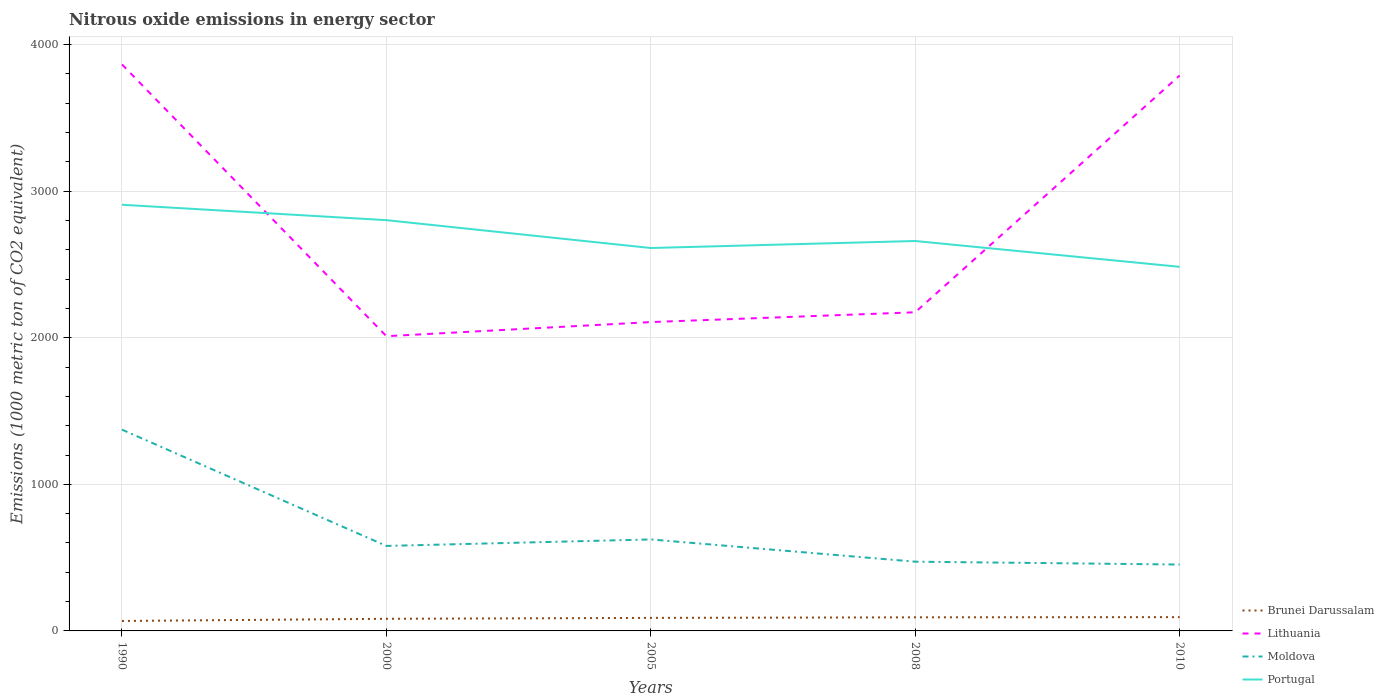How many different coloured lines are there?
Your answer should be compact. 4. Does the line corresponding to Moldova intersect with the line corresponding to Brunei Darussalam?
Offer a very short reply. No. Is the number of lines equal to the number of legend labels?
Give a very brief answer. Yes. Across all years, what is the maximum amount of nitrous oxide emitted in Moldova?
Give a very brief answer. 452.9. In which year was the amount of nitrous oxide emitted in Moldova maximum?
Your response must be concise. 2010. What is the total amount of nitrous oxide emitted in Moldova in the graph?
Offer a terse response. 793.4. What is the difference between the highest and the second highest amount of nitrous oxide emitted in Portugal?
Your answer should be very brief. 423.5. What is the difference between the highest and the lowest amount of nitrous oxide emitted in Portugal?
Your answer should be very brief. 2. Does the graph contain grids?
Keep it short and to the point. Yes. How are the legend labels stacked?
Keep it short and to the point. Vertical. What is the title of the graph?
Offer a very short reply. Nitrous oxide emissions in energy sector. What is the label or title of the X-axis?
Provide a short and direct response. Years. What is the label or title of the Y-axis?
Your response must be concise. Emissions (1000 metric ton of CO2 equivalent). What is the Emissions (1000 metric ton of CO2 equivalent) in Brunei Darussalam in 1990?
Make the answer very short. 67.9. What is the Emissions (1000 metric ton of CO2 equivalent) of Lithuania in 1990?
Give a very brief answer. 3865. What is the Emissions (1000 metric ton of CO2 equivalent) in Moldova in 1990?
Your answer should be compact. 1373.3. What is the Emissions (1000 metric ton of CO2 equivalent) in Portugal in 1990?
Offer a very short reply. 2907.5. What is the Emissions (1000 metric ton of CO2 equivalent) in Brunei Darussalam in 2000?
Provide a succinct answer. 82.7. What is the Emissions (1000 metric ton of CO2 equivalent) in Lithuania in 2000?
Your answer should be compact. 2010.8. What is the Emissions (1000 metric ton of CO2 equivalent) in Moldova in 2000?
Offer a terse response. 579.9. What is the Emissions (1000 metric ton of CO2 equivalent) in Portugal in 2000?
Your answer should be very brief. 2802.4. What is the Emissions (1000 metric ton of CO2 equivalent) of Brunei Darussalam in 2005?
Offer a very short reply. 88.9. What is the Emissions (1000 metric ton of CO2 equivalent) of Lithuania in 2005?
Give a very brief answer. 2107. What is the Emissions (1000 metric ton of CO2 equivalent) in Moldova in 2005?
Keep it short and to the point. 624.1. What is the Emissions (1000 metric ton of CO2 equivalent) of Portugal in 2005?
Your answer should be very brief. 2612.4. What is the Emissions (1000 metric ton of CO2 equivalent) in Brunei Darussalam in 2008?
Give a very brief answer. 92.7. What is the Emissions (1000 metric ton of CO2 equivalent) in Lithuania in 2008?
Make the answer very short. 2173.9. What is the Emissions (1000 metric ton of CO2 equivalent) of Moldova in 2008?
Provide a short and direct response. 472.4. What is the Emissions (1000 metric ton of CO2 equivalent) in Portugal in 2008?
Provide a succinct answer. 2660.2. What is the Emissions (1000 metric ton of CO2 equivalent) in Brunei Darussalam in 2010?
Give a very brief answer. 94.1. What is the Emissions (1000 metric ton of CO2 equivalent) in Lithuania in 2010?
Give a very brief answer. 3789.1. What is the Emissions (1000 metric ton of CO2 equivalent) of Moldova in 2010?
Keep it short and to the point. 452.9. What is the Emissions (1000 metric ton of CO2 equivalent) in Portugal in 2010?
Your answer should be very brief. 2484. Across all years, what is the maximum Emissions (1000 metric ton of CO2 equivalent) of Brunei Darussalam?
Your response must be concise. 94.1. Across all years, what is the maximum Emissions (1000 metric ton of CO2 equivalent) in Lithuania?
Offer a very short reply. 3865. Across all years, what is the maximum Emissions (1000 metric ton of CO2 equivalent) in Moldova?
Keep it short and to the point. 1373.3. Across all years, what is the maximum Emissions (1000 metric ton of CO2 equivalent) in Portugal?
Give a very brief answer. 2907.5. Across all years, what is the minimum Emissions (1000 metric ton of CO2 equivalent) in Brunei Darussalam?
Offer a very short reply. 67.9. Across all years, what is the minimum Emissions (1000 metric ton of CO2 equivalent) of Lithuania?
Keep it short and to the point. 2010.8. Across all years, what is the minimum Emissions (1000 metric ton of CO2 equivalent) in Moldova?
Offer a terse response. 452.9. Across all years, what is the minimum Emissions (1000 metric ton of CO2 equivalent) in Portugal?
Provide a succinct answer. 2484. What is the total Emissions (1000 metric ton of CO2 equivalent) in Brunei Darussalam in the graph?
Your answer should be very brief. 426.3. What is the total Emissions (1000 metric ton of CO2 equivalent) in Lithuania in the graph?
Your answer should be compact. 1.39e+04. What is the total Emissions (1000 metric ton of CO2 equivalent) of Moldova in the graph?
Offer a very short reply. 3502.6. What is the total Emissions (1000 metric ton of CO2 equivalent) in Portugal in the graph?
Offer a terse response. 1.35e+04. What is the difference between the Emissions (1000 metric ton of CO2 equivalent) in Brunei Darussalam in 1990 and that in 2000?
Provide a short and direct response. -14.8. What is the difference between the Emissions (1000 metric ton of CO2 equivalent) in Lithuania in 1990 and that in 2000?
Ensure brevity in your answer.  1854.2. What is the difference between the Emissions (1000 metric ton of CO2 equivalent) in Moldova in 1990 and that in 2000?
Your answer should be very brief. 793.4. What is the difference between the Emissions (1000 metric ton of CO2 equivalent) in Portugal in 1990 and that in 2000?
Your answer should be very brief. 105.1. What is the difference between the Emissions (1000 metric ton of CO2 equivalent) in Brunei Darussalam in 1990 and that in 2005?
Give a very brief answer. -21. What is the difference between the Emissions (1000 metric ton of CO2 equivalent) in Lithuania in 1990 and that in 2005?
Keep it short and to the point. 1758. What is the difference between the Emissions (1000 metric ton of CO2 equivalent) in Moldova in 1990 and that in 2005?
Offer a terse response. 749.2. What is the difference between the Emissions (1000 metric ton of CO2 equivalent) in Portugal in 1990 and that in 2005?
Your answer should be very brief. 295.1. What is the difference between the Emissions (1000 metric ton of CO2 equivalent) of Brunei Darussalam in 1990 and that in 2008?
Keep it short and to the point. -24.8. What is the difference between the Emissions (1000 metric ton of CO2 equivalent) in Lithuania in 1990 and that in 2008?
Offer a terse response. 1691.1. What is the difference between the Emissions (1000 metric ton of CO2 equivalent) in Moldova in 1990 and that in 2008?
Ensure brevity in your answer.  900.9. What is the difference between the Emissions (1000 metric ton of CO2 equivalent) of Portugal in 1990 and that in 2008?
Offer a very short reply. 247.3. What is the difference between the Emissions (1000 metric ton of CO2 equivalent) of Brunei Darussalam in 1990 and that in 2010?
Your answer should be compact. -26.2. What is the difference between the Emissions (1000 metric ton of CO2 equivalent) in Lithuania in 1990 and that in 2010?
Provide a short and direct response. 75.9. What is the difference between the Emissions (1000 metric ton of CO2 equivalent) of Moldova in 1990 and that in 2010?
Your answer should be compact. 920.4. What is the difference between the Emissions (1000 metric ton of CO2 equivalent) in Portugal in 1990 and that in 2010?
Your answer should be very brief. 423.5. What is the difference between the Emissions (1000 metric ton of CO2 equivalent) in Lithuania in 2000 and that in 2005?
Your response must be concise. -96.2. What is the difference between the Emissions (1000 metric ton of CO2 equivalent) in Moldova in 2000 and that in 2005?
Your response must be concise. -44.2. What is the difference between the Emissions (1000 metric ton of CO2 equivalent) of Portugal in 2000 and that in 2005?
Make the answer very short. 190. What is the difference between the Emissions (1000 metric ton of CO2 equivalent) in Brunei Darussalam in 2000 and that in 2008?
Give a very brief answer. -10. What is the difference between the Emissions (1000 metric ton of CO2 equivalent) in Lithuania in 2000 and that in 2008?
Your answer should be compact. -163.1. What is the difference between the Emissions (1000 metric ton of CO2 equivalent) of Moldova in 2000 and that in 2008?
Your response must be concise. 107.5. What is the difference between the Emissions (1000 metric ton of CO2 equivalent) in Portugal in 2000 and that in 2008?
Ensure brevity in your answer.  142.2. What is the difference between the Emissions (1000 metric ton of CO2 equivalent) of Lithuania in 2000 and that in 2010?
Keep it short and to the point. -1778.3. What is the difference between the Emissions (1000 metric ton of CO2 equivalent) in Moldova in 2000 and that in 2010?
Ensure brevity in your answer.  127. What is the difference between the Emissions (1000 metric ton of CO2 equivalent) of Portugal in 2000 and that in 2010?
Provide a succinct answer. 318.4. What is the difference between the Emissions (1000 metric ton of CO2 equivalent) in Lithuania in 2005 and that in 2008?
Your response must be concise. -66.9. What is the difference between the Emissions (1000 metric ton of CO2 equivalent) of Moldova in 2005 and that in 2008?
Your answer should be very brief. 151.7. What is the difference between the Emissions (1000 metric ton of CO2 equivalent) of Portugal in 2005 and that in 2008?
Keep it short and to the point. -47.8. What is the difference between the Emissions (1000 metric ton of CO2 equivalent) in Brunei Darussalam in 2005 and that in 2010?
Make the answer very short. -5.2. What is the difference between the Emissions (1000 metric ton of CO2 equivalent) of Lithuania in 2005 and that in 2010?
Provide a short and direct response. -1682.1. What is the difference between the Emissions (1000 metric ton of CO2 equivalent) of Moldova in 2005 and that in 2010?
Provide a short and direct response. 171.2. What is the difference between the Emissions (1000 metric ton of CO2 equivalent) of Portugal in 2005 and that in 2010?
Your response must be concise. 128.4. What is the difference between the Emissions (1000 metric ton of CO2 equivalent) in Brunei Darussalam in 2008 and that in 2010?
Your response must be concise. -1.4. What is the difference between the Emissions (1000 metric ton of CO2 equivalent) in Lithuania in 2008 and that in 2010?
Your response must be concise. -1615.2. What is the difference between the Emissions (1000 metric ton of CO2 equivalent) of Portugal in 2008 and that in 2010?
Offer a terse response. 176.2. What is the difference between the Emissions (1000 metric ton of CO2 equivalent) of Brunei Darussalam in 1990 and the Emissions (1000 metric ton of CO2 equivalent) of Lithuania in 2000?
Ensure brevity in your answer.  -1942.9. What is the difference between the Emissions (1000 metric ton of CO2 equivalent) in Brunei Darussalam in 1990 and the Emissions (1000 metric ton of CO2 equivalent) in Moldova in 2000?
Offer a terse response. -512. What is the difference between the Emissions (1000 metric ton of CO2 equivalent) of Brunei Darussalam in 1990 and the Emissions (1000 metric ton of CO2 equivalent) of Portugal in 2000?
Your answer should be compact. -2734.5. What is the difference between the Emissions (1000 metric ton of CO2 equivalent) of Lithuania in 1990 and the Emissions (1000 metric ton of CO2 equivalent) of Moldova in 2000?
Offer a very short reply. 3285.1. What is the difference between the Emissions (1000 metric ton of CO2 equivalent) of Lithuania in 1990 and the Emissions (1000 metric ton of CO2 equivalent) of Portugal in 2000?
Your response must be concise. 1062.6. What is the difference between the Emissions (1000 metric ton of CO2 equivalent) in Moldova in 1990 and the Emissions (1000 metric ton of CO2 equivalent) in Portugal in 2000?
Keep it short and to the point. -1429.1. What is the difference between the Emissions (1000 metric ton of CO2 equivalent) of Brunei Darussalam in 1990 and the Emissions (1000 metric ton of CO2 equivalent) of Lithuania in 2005?
Offer a terse response. -2039.1. What is the difference between the Emissions (1000 metric ton of CO2 equivalent) in Brunei Darussalam in 1990 and the Emissions (1000 metric ton of CO2 equivalent) in Moldova in 2005?
Give a very brief answer. -556.2. What is the difference between the Emissions (1000 metric ton of CO2 equivalent) of Brunei Darussalam in 1990 and the Emissions (1000 metric ton of CO2 equivalent) of Portugal in 2005?
Offer a terse response. -2544.5. What is the difference between the Emissions (1000 metric ton of CO2 equivalent) in Lithuania in 1990 and the Emissions (1000 metric ton of CO2 equivalent) in Moldova in 2005?
Keep it short and to the point. 3240.9. What is the difference between the Emissions (1000 metric ton of CO2 equivalent) of Lithuania in 1990 and the Emissions (1000 metric ton of CO2 equivalent) of Portugal in 2005?
Your answer should be compact. 1252.6. What is the difference between the Emissions (1000 metric ton of CO2 equivalent) of Moldova in 1990 and the Emissions (1000 metric ton of CO2 equivalent) of Portugal in 2005?
Ensure brevity in your answer.  -1239.1. What is the difference between the Emissions (1000 metric ton of CO2 equivalent) in Brunei Darussalam in 1990 and the Emissions (1000 metric ton of CO2 equivalent) in Lithuania in 2008?
Ensure brevity in your answer.  -2106. What is the difference between the Emissions (1000 metric ton of CO2 equivalent) in Brunei Darussalam in 1990 and the Emissions (1000 metric ton of CO2 equivalent) in Moldova in 2008?
Offer a terse response. -404.5. What is the difference between the Emissions (1000 metric ton of CO2 equivalent) in Brunei Darussalam in 1990 and the Emissions (1000 metric ton of CO2 equivalent) in Portugal in 2008?
Your answer should be very brief. -2592.3. What is the difference between the Emissions (1000 metric ton of CO2 equivalent) in Lithuania in 1990 and the Emissions (1000 metric ton of CO2 equivalent) in Moldova in 2008?
Offer a terse response. 3392.6. What is the difference between the Emissions (1000 metric ton of CO2 equivalent) in Lithuania in 1990 and the Emissions (1000 metric ton of CO2 equivalent) in Portugal in 2008?
Give a very brief answer. 1204.8. What is the difference between the Emissions (1000 metric ton of CO2 equivalent) in Moldova in 1990 and the Emissions (1000 metric ton of CO2 equivalent) in Portugal in 2008?
Keep it short and to the point. -1286.9. What is the difference between the Emissions (1000 metric ton of CO2 equivalent) of Brunei Darussalam in 1990 and the Emissions (1000 metric ton of CO2 equivalent) of Lithuania in 2010?
Provide a succinct answer. -3721.2. What is the difference between the Emissions (1000 metric ton of CO2 equivalent) of Brunei Darussalam in 1990 and the Emissions (1000 metric ton of CO2 equivalent) of Moldova in 2010?
Provide a short and direct response. -385. What is the difference between the Emissions (1000 metric ton of CO2 equivalent) of Brunei Darussalam in 1990 and the Emissions (1000 metric ton of CO2 equivalent) of Portugal in 2010?
Your answer should be very brief. -2416.1. What is the difference between the Emissions (1000 metric ton of CO2 equivalent) in Lithuania in 1990 and the Emissions (1000 metric ton of CO2 equivalent) in Moldova in 2010?
Your answer should be compact. 3412.1. What is the difference between the Emissions (1000 metric ton of CO2 equivalent) of Lithuania in 1990 and the Emissions (1000 metric ton of CO2 equivalent) of Portugal in 2010?
Offer a terse response. 1381. What is the difference between the Emissions (1000 metric ton of CO2 equivalent) of Moldova in 1990 and the Emissions (1000 metric ton of CO2 equivalent) of Portugal in 2010?
Your answer should be compact. -1110.7. What is the difference between the Emissions (1000 metric ton of CO2 equivalent) in Brunei Darussalam in 2000 and the Emissions (1000 metric ton of CO2 equivalent) in Lithuania in 2005?
Provide a short and direct response. -2024.3. What is the difference between the Emissions (1000 metric ton of CO2 equivalent) in Brunei Darussalam in 2000 and the Emissions (1000 metric ton of CO2 equivalent) in Moldova in 2005?
Your answer should be very brief. -541.4. What is the difference between the Emissions (1000 metric ton of CO2 equivalent) of Brunei Darussalam in 2000 and the Emissions (1000 metric ton of CO2 equivalent) of Portugal in 2005?
Provide a short and direct response. -2529.7. What is the difference between the Emissions (1000 metric ton of CO2 equivalent) in Lithuania in 2000 and the Emissions (1000 metric ton of CO2 equivalent) in Moldova in 2005?
Provide a short and direct response. 1386.7. What is the difference between the Emissions (1000 metric ton of CO2 equivalent) of Lithuania in 2000 and the Emissions (1000 metric ton of CO2 equivalent) of Portugal in 2005?
Give a very brief answer. -601.6. What is the difference between the Emissions (1000 metric ton of CO2 equivalent) in Moldova in 2000 and the Emissions (1000 metric ton of CO2 equivalent) in Portugal in 2005?
Ensure brevity in your answer.  -2032.5. What is the difference between the Emissions (1000 metric ton of CO2 equivalent) in Brunei Darussalam in 2000 and the Emissions (1000 metric ton of CO2 equivalent) in Lithuania in 2008?
Provide a succinct answer. -2091.2. What is the difference between the Emissions (1000 metric ton of CO2 equivalent) in Brunei Darussalam in 2000 and the Emissions (1000 metric ton of CO2 equivalent) in Moldova in 2008?
Provide a succinct answer. -389.7. What is the difference between the Emissions (1000 metric ton of CO2 equivalent) of Brunei Darussalam in 2000 and the Emissions (1000 metric ton of CO2 equivalent) of Portugal in 2008?
Keep it short and to the point. -2577.5. What is the difference between the Emissions (1000 metric ton of CO2 equivalent) of Lithuania in 2000 and the Emissions (1000 metric ton of CO2 equivalent) of Moldova in 2008?
Ensure brevity in your answer.  1538.4. What is the difference between the Emissions (1000 metric ton of CO2 equivalent) of Lithuania in 2000 and the Emissions (1000 metric ton of CO2 equivalent) of Portugal in 2008?
Your answer should be very brief. -649.4. What is the difference between the Emissions (1000 metric ton of CO2 equivalent) of Moldova in 2000 and the Emissions (1000 metric ton of CO2 equivalent) of Portugal in 2008?
Keep it short and to the point. -2080.3. What is the difference between the Emissions (1000 metric ton of CO2 equivalent) in Brunei Darussalam in 2000 and the Emissions (1000 metric ton of CO2 equivalent) in Lithuania in 2010?
Ensure brevity in your answer.  -3706.4. What is the difference between the Emissions (1000 metric ton of CO2 equivalent) of Brunei Darussalam in 2000 and the Emissions (1000 metric ton of CO2 equivalent) of Moldova in 2010?
Provide a succinct answer. -370.2. What is the difference between the Emissions (1000 metric ton of CO2 equivalent) in Brunei Darussalam in 2000 and the Emissions (1000 metric ton of CO2 equivalent) in Portugal in 2010?
Provide a succinct answer. -2401.3. What is the difference between the Emissions (1000 metric ton of CO2 equivalent) in Lithuania in 2000 and the Emissions (1000 metric ton of CO2 equivalent) in Moldova in 2010?
Make the answer very short. 1557.9. What is the difference between the Emissions (1000 metric ton of CO2 equivalent) in Lithuania in 2000 and the Emissions (1000 metric ton of CO2 equivalent) in Portugal in 2010?
Keep it short and to the point. -473.2. What is the difference between the Emissions (1000 metric ton of CO2 equivalent) of Moldova in 2000 and the Emissions (1000 metric ton of CO2 equivalent) of Portugal in 2010?
Offer a very short reply. -1904.1. What is the difference between the Emissions (1000 metric ton of CO2 equivalent) of Brunei Darussalam in 2005 and the Emissions (1000 metric ton of CO2 equivalent) of Lithuania in 2008?
Your response must be concise. -2085. What is the difference between the Emissions (1000 metric ton of CO2 equivalent) of Brunei Darussalam in 2005 and the Emissions (1000 metric ton of CO2 equivalent) of Moldova in 2008?
Provide a succinct answer. -383.5. What is the difference between the Emissions (1000 metric ton of CO2 equivalent) of Brunei Darussalam in 2005 and the Emissions (1000 metric ton of CO2 equivalent) of Portugal in 2008?
Make the answer very short. -2571.3. What is the difference between the Emissions (1000 metric ton of CO2 equivalent) in Lithuania in 2005 and the Emissions (1000 metric ton of CO2 equivalent) in Moldova in 2008?
Offer a terse response. 1634.6. What is the difference between the Emissions (1000 metric ton of CO2 equivalent) in Lithuania in 2005 and the Emissions (1000 metric ton of CO2 equivalent) in Portugal in 2008?
Give a very brief answer. -553.2. What is the difference between the Emissions (1000 metric ton of CO2 equivalent) of Moldova in 2005 and the Emissions (1000 metric ton of CO2 equivalent) of Portugal in 2008?
Your answer should be very brief. -2036.1. What is the difference between the Emissions (1000 metric ton of CO2 equivalent) in Brunei Darussalam in 2005 and the Emissions (1000 metric ton of CO2 equivalent) in Lithuania in 2010?
Make the answer very short. -3700.2. What is the difference between the Emissions (1000 metric ton of CO2 equivalent) in Brunei Darussalam in 2005 and the Emissions (1000 metric ton of CO2 equivalent) in Moldova in 2010?
Keep it short and to the point. -364. What is the difference between the Emissions (1000 metric ton of CO2 equivalent) in Brunei Darussalam in 2005 and the Emissions (1000 metric ton of CO2 equivalent) in Portugal in 2010?
Your answer should be compact. -2395.1. What is the difference between the Emissions (1000 metric ton of CO2 equivalent) in Lithuania in 2005 and the Emissions (1000 metric ton of CO2 equivalent) in Moldova in 2010?
Offer a very short reply. 1654.1. What is the difference between the Emissions (1000 metric ton of CO2 equivalent) of Lithuania in 2005 and the Emissions (1000 metric ton of CO2 equivalent) of Portugal in 2010?
Provide a succinct answer. -377. What is the difference between the Emissions (1000 metric ton of CO2 equivalent) of Moldova in 2005 and the Emissions (1000 metric ton of CO2 equivalent) of Portugal in 2010?
Your answer should be compact. -1859.9. What is the difference between the Emissions (1000 metric ton of CO2 equivalent) in Brunei Darussalam in 2008 and the Emissions (1000 metric ton of CO2 equivalent) in Lithuania in 2010?
Make the answer very short. -3696.4. What is the difference between the Emissions (1000 metric ton of CO2 equivalent) of Brunei Darussalam in 2008 and the Emissions (1000 metric ton of CO2 equivalent) of Moldova in 2010?
Your answer should be compact. -360.2. What is the difference between the Emissions (1000 metric ton of CO2 equivalent) in Brunei Darussalam in 2008 and the Emissions (1000 metric ton of CO2 equivalent) in Portugal in 2010?
Your answer should be compact. -2391.3. What is the difference between the Emissions (1000 metric ton of CO2 equivalent) in Lithuania in 2008 and the Emissions (1000 metric ton of CO2 equivalent) in Moldova in 2010?
Give a very brief answer. 1721. What is the difference between the Emissions (1000 metric ton of CO2 equivalent) in Lithuania in 2008 and the Emissions (1000 metric ton of CO2 equivalent) in Portugal in 2010?
Provide a short and direct response. -310.1. What is the difference between the Emissions (1000 metric ton of CO2 equivalent) of Moldova in 2008 and the Emissions (1000 metric ton of CO2 equivalent) of Portugal in 2010?
Provide a short and direct response. -2011.6. What is the average Emissions (1000 metric ton of CO2 equivalent) of Brunei Darussalam per year?
Provide a short and direct response. 85.26. What is the average Emissions (1000 metric ton of CO2 equivalent) of Lithuania per year?
Keep it short and to the point. 2789.16. What is the average Emissions (1000 metric ton of CO2 equivalent) of Moldova per year?
Make the answer very short. 700.52. What is the average Emissions (1000 metric ton of CO2 equivalent) of Portugal per year?
Your response must be concise. 2693.3. In the year 1990, what is the difference between the Emissions (1000 metric ton of CO2 equivalent) of Brunei Darussalam and Emissions (1000 metric ton of CO2 equivalent) of Lithuania?
Keep it short and to the point. -3797.1. In the year 1990, what is the difference between the Emissions (1000 metric ton of CO2 equivalent) in Brunei Darussalam and Emissions (1000 metric ton of CO2 equivalent) in Moldova?
Ensure brevity in your answer.  -1305.4. In the year 1990, what is the difference between the Emissions (1000 metric ton of CO2 equivalent) of Brunei Darussalam and Emissions (1000 metric ton of CO2 equivalent) of Portugal?
Ensure brevity in your answer.  -2839.6. In the year 1990, what is the difference between the Emissions (1000 metric ton of CO2 equivalent) in Lithuania and Emissions (1000 metric ton of CO2 equivalent) in Moldova?
Offer a terse response. 2491.7. In the year 1990, what is the difference between the Emissions (1000 metric ton of CO2 equivalent) of Lithuania and Emissions (1000 metric ton of CO2 equivalent) of Portugal?
Ensure brevity in your answer.  957.5. In the year 1990, what is the difference between the Emissions (1000 metric ton of CO2 equivalent) in Moldova and Emissions (1000 metric ton of CO2 equivalent) in Portugal?
Give a very brief answer. -1534.2. In the year 2000, what is the difference between the Emissions (1000 metric ton of CO2 equivalent) in Brunei Darussalam and Emissions (1000 metric ton of CO2 equivalent) in Lithuania?
Your answer should be compact. -1928.1. In the year 2000, what is the difference between the Emissions (1000 metric ton of CO2 equivalent) of Brunei Darussalam and Emissions (1000 metric ton of CO2 equivalent) of Moldova?
Make the answer very short. -497.2. In the year 2000, what is the difference between the Emissions (1000 metric ton of CO2 equivalent) in Brunei Darussalam and Emissions (1000 metric ton of CO2 equivalent) in Portugal?
Give a very brief answer. -2719.7. In the year 2000, what is the difference between the Emissions (1000 metric ton of CO2 equivalent) of Lithuania and Emissions (1000 metric ton of CO2 equivalent) of Moldova?
Provide a succinct answer. 1430.9. In the year 2000, what is the difference between the Emissions (1000 metric ton of CO2 equivalent) in Lithuania and Emissions (1000 metric ton of CO2 equivalent) in Portugal?
Your answer should be compact. -791.6. In the year 2000, what is the difference between the Emissions (1000 metric ton of CO2 equivalent) of Moldova and Emissions (1000 metric ton of CO2 equivalent) of Portugal?
Make the answer very short. -2222.5. In the year 2005, what is the difference between the Emissions (1000 metric ton of CO2 equivalent) in Brunei Darussalam and Emissions (1000 metric ton of CO2 equivalent) in Lithuania?
Give a very brief answer. -2018.1. In the year 2005, what is the difference between the Emissions (1000 metric ton of CO2 equivalent) of Brunei Darussalam and Emissions (1000 metric ton of CO2 equivalent) of Moldova?
Give a very brief answer. -535.2. In the year 2005, what is the difference between the Emissions (1000 metric ton of CO2 equivalent) of Brunei Darussalam and Emissions (1000 metric ton of CO2 equivalent) of Portugal?
Offer a very short reply. -2523.5. In the year 2005, what is the difference between the Emissions (1000 metric ton of CO2 equivalent) of Lithuania and Emissions (1000 metric ton of CO2 equivalent) of Moldova?
Provide a succinct answer. 1482.9. In the year 2005, what is the difference between the Emissions (1000 metric ton of CO2 equivalent) of Lithuania and Emissions (1000 metric ton of CO2 equivalent) of Portugal?
Your answer should be very brief. -505.4. In the year 2005, what is the difference between the Emissions (1000 metric ton of CO2 equivalent) in Moldova and Emissions (1000 metric ton of CO2 equivalent) in Portugal?
Ensure brevity in your answer.  -1988.3. In the year 2008, what is the difference between the Emissions (1000 metric ton of CO2 equivalent) in Brunei Darussalam and Emissions (1000 metric ton of CO2 equivalent) in Lithuania?
Keep it short and to the point. -2081.2. In the year 2008, what is the difference between the Emissions (1000 metric ton of CO2 equivalent) of Brunei Darussalam and Emissions (1000 metric ton of CO2 equivalent) of Moldova?
Ensure brevity in your answer.  -379.7. In the year 2008, what is the difference between the Emissions (1000 metric ton of CO2 equivalent) in Brunei Darussalam and Emissions (1000 metric ton of CO2 equivalent) in Portugal?
Offer a very short reply. -2567.5. In the year 2008, what is the difference between the Emissions (1000 metric ton of CO2 equivalent) in Lithuania and Emissions (1000 metric ton of CO2 equivalent) in Moldova?
Offer a very short reply. 1701.5. In the year 2008, what is the difference between the Emissions (1000 metric ton of CO2 equivalent) in Lithuania and Emissions (1000 metric ton of CO2 equivalent) in Portugal?
Provide a short and direct response. -486.3. In the year 2008, what is the difference between the Emissions (1000 metric ton of CO2 equivalent) of Moldova and Emissions (1000 metric ton of CO2 equivalent) of Portugal?
Your response must be concise. -2187.8. In the year 2010, what is the difference between the Emissions (1000 metric ton of CO2 equivalent) in Brunei Darussalam and Emissions (1000 metric ton of CO2 equivalent) in Lithuania?
Your answer should be compact. -3695. In the year 2010, what is the difference between the Emissions (1000 metric ton of CO2 equivalent) in Brunei Darussalam and Emissions (1000 metric ton of CO2 equivalent) in Moldova?
Make the answer very short. -358.8. In the year 2010, what is the difference between the Emissions (1000 metric ton of CO2 equivalent) in Brunei Darussalam and Emissions (1000 metric ton of CO2 equivalent) in Portugal?
Your answer should be compact. -2389.9. In the year 2010, what is the difference between the Emissions (1000 metric ton of CO2 equivalent) in Lithuania and Emissions (1000 metric ton of CO2 equivalent) in Moldova?
Ensure brevity in your answer.  3336.2. In the year 2010, what is the difference between the Emissions (1000 metric ton of CO2 equivalent) in Lithuania and Emissions (1000 metric ton of CO2 equivalent) in Portugal?
Make the answer very short. 1305.1. In the year 2010, what is the difference between the Emissions (1000 metric ton of CO2 equivalent) of Moldova and Emissions (1000 metric ton of CO2 equivalent) of Portugal?
Ensure brevity in your answer.  -2031.1. What is the ratio of the Emissions (1000 metric ton of CO2 equivalent) of Brunei Darussalam in 1990 to that in 2000?
Make the answer very short. 0.82. What is the ratio of the Emissions (1000 metric ton of CO2 equivalent) of Lithuania in 1990 to that in 2000?
Give a very brief answer. 1.92. What is the ratio of the Emissions (1000 metric ton of CO2 equivalent) in Moldova in 1990 to that in 2000?
Ensure brevity in your answer.  2.37. What is the ratio of the Emissions (1000 metric ton of CO2 equivalent) in Portugal in 1990 to that in 2000?
Your answer should be compact. 1.04. What is the ratio of the Emissions (1000 metric ton of CO2 equivalent) of Brunei Darussalam in 1990 to that in 2005?
Ensure brevity in your answer.  0.76. What is the ratio of the Emissions (1000 metric ton of CO2 equivalent) in Lithuania in 1990 to that in 2005?
Give a very brief answer. 1.83. What is the ratio of the Emissions (1000 metric ton of CO2 equivalent) of Moldova in 1990 to that in 2005?
Make the answer very short. 2.2. What is the ratio of the Emissions (1000 metric ton of CO2 equivalent) of Portugal in 1990 to that in 2005?
Provide a short and direct response. 1.11. What is the ratio of the Emissions (1000 metric ton of CO2 equivalent) in Brunei Darussalam in 1990 to that in 2008?
Give a very brief answer. 0.73. What is the ratio of the Emissions (1000 metric ton of CO2 equivalent) in Lithuania in 1990 to that in 2008?
Give a very brief answer. 1.78. What is the ratio of the Emissions (1000 metric ton of CO2 equivalent) in Moldova in 1990 to that in 2008?
Your answer should be very brief. 2.91. What is the ratio of the Emissions (1000 metric ton of CO2 equivalent) in Portugal in 1990 to that in 2008?
Keep it short and to the point. 1.09. What is the ratio of the Emissions (1000 metric ton of CO2 equivalent) in Brunei Darussalam in 1990 to that in 2010?
Ensure brevity in your answer.  0.72. What is the ratio of the Emissions (1000 metric ton of CO2 equivalent) of Lithuania in 1990 to that in 2010?
Your answer should be compact. 1.02. What is the ratio of the Emissions (1000 metric ton of CO2 equivalent) in Moldova in 1990 to that in 2010?
Give a very brief answer. 3.03. What is the ratio of the Emissions (1000 metric ton of CO2 equivalent) of Portugal in 1990 to that in 2010?
Your response must be concise. 1.17. What is the ratio of the Emissions (1000 metric ton of CO2 equivalent) in Brunei Darussalam in 2000 to that in 2005?
Keep it short and to the point. 0.93. What is the ratio of the Emissions (1000 metric ton of CO2 equivalent) in Lithuania in 2000 to that in 2005?
Give a very brief answer. 0.95. What is the ratio of the Emissions (1000 metric ton of CO2 equivalent) in Moldova in 2000 to that in 2005?
Keep it short and to the point. 0.93. What is the ratio of the Emissions (1000 metric ton of CO2 equivalent) of Portugal in 2000 to that in 2005?
Provide a succinct answer. 1.07. What is the ratio of the Emissions (1000 metric ton of CO2 equivalent) of Brunei Darussalam in 2000 to that in 2008?
Keep it short and to the point. 0.89. What is the ratio of the Emissions (1000 metric ton of CO2 equivalent) in Lithuania in 2000 to that in 2008?
Make the answer very short. 0.93. What is the ratio of the Emissions (1000 metric ton of CO2 equivalent) in Moldova in 2000 to that in 2008?
Give a very brief answer. 1.23. What is the ratio of the Emissions (1000 metric ton of CO2 equivalent) of Portugal in 2000 to that in 2008?
Offer a terse response. 1.05. What is the ratio of the Emissions (1000 metric ton of CO2 equivalent) of Brunei Darussalam in 2000 to that in 2010?
Keep it short and to the point. 0.88. What is the ratio of the Emissions (1000 metric ton of CO2 equivalent) in Lithuania in 2000 to that in 2010?
Provide a succinct answer. 0.53. What is the ratio of the Emissions (1000 metric ton of CO2 equivalent) in Moldova in 2000 to that in 2010?
Your response must be concise. 1.28. What is the ratio of the Emissions (1000 metric ton of CO2 equivalent) in Portugal in 2000 to that in 2010?
Give a very brief answer. 1.13. What is the ratio of the Emissions (1000 metric ton of CO2 equivalent) of Brunei Darussalam in 2005 to that in 2008?
Your answer should be very brief. 0.96. What is the ratio of the Emissions (1000 metric ton of CO2 equivalent) of Lithuania in 2005 to that in 2008?
Offer a very short reply. 0.97. What is the ratio of the Emissions (1000 metric ton of CO2 equivalent) in Moldova in 2005 to that in 2008?
Your answer should be very brief. 1.32. What is the ratio of the Emissions (1000 metric ton of CO2 equivalent) of Brunei Darussalam in 2005 to that in 2010?
Offer a terse response. 0.94. What is the ratio of the Emissions (1000 metric ton of CO2 equivalent) of Lithuania in 2005 to that in 2010?
Your answer should be compact. 0.56. What is the ratio of the Emissions (1000 metric ton of CO2 equivalent) in Moldova in 2005 to that in 2010?
Make the answer very short. 1.38. What is the ratio of the Emissions (1000 metric ton of CO2 equivalent) of Portugal in 2005 to that in 2010?
Offer a terse response. 1.05. What is the ratio of the Emissions (1000 metric ton of CO2 equivalent) of Brunei Darussalam in 2008 to that in 2010?
Ensure brevity in your answer.  0.99. What is the ratio of the Emissions (1000 metric ton of CO2 equivalent) in Lithuania in 2008 to that in 2010?
Provide a short and direct response. 0.57. What is the ratio of the Emissions (1000 metric ton of CO2 equivalent) in Moldova in 2008 to that in 2010?
Your answer should be very brief. 1.04. What is the ratio of the Emissions (1000 metric ton of CO2 equivalent) in Portugal in 2008 to that in 2010?
Offer a terse response. 1.07. What is the difference between the highest and the second highest Emissions (1000 metric ton of CO2 equivalent) in Lithuania?
Your answer should be compact. 75.9. What is the difference between the highest and the second highest Emissions (1000 metric ton of CO2 equivalent) in Moldova?
Keep it short and to the point. 749.2. What is the difference between the highest and the second highest Emissions (1000 metric ton of CO2 equivalent) of Portugal?
Provide a succinct answer. 105.1. What is the difference between the highest and the lowest Emissions (1000 metric ton of CO2 equivalent) in Brunei Darussalam?
Your answer should be compact. 26.2. What is the difference between the highest and the lowest Emissions (1000 metric ton of CO2 equivalent) in Lithuania?
Give a very brief answer. 1854.2. What is the difference between the highest and the lowest Emissions (1000 metric ton of CO2 equivalent) in Moldova?
Offer a terse response. 920.4. What is the difference between the highest and the lowest Emissions (1000 metric ton of CO2 equivalent) of Portugal?
Offer a terse response. 423.5. 